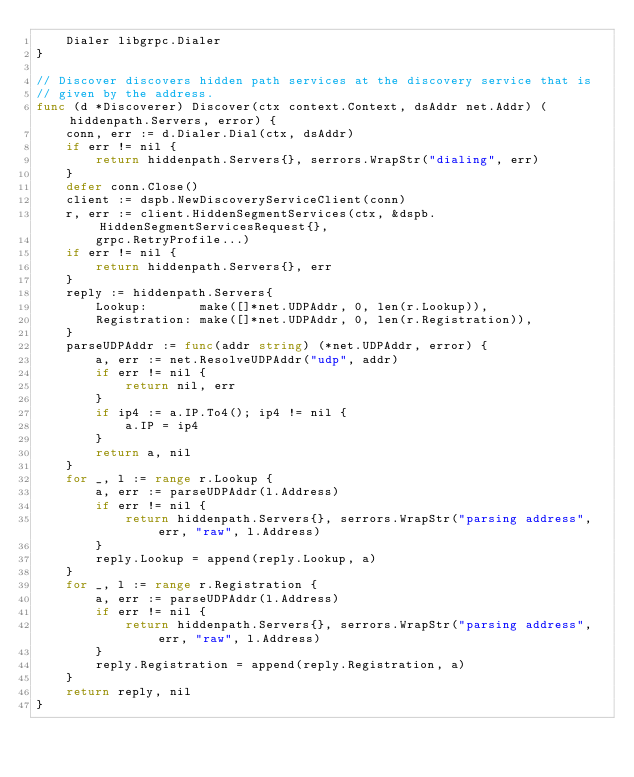Convert code to text. <code><loc_0><loc_0><loc_500><loc_500><_Go_>	Dialer libgrpc.Dialer
}

// Discover discovers hidden path services at the discovery service that is
// given by the address.
func (d *Discoverer) Discover(ctx context.Context, dsAddr net.Addr) (hiddenpath.Servers, error) {
	conn, err := d.Dialer.Dial(ctx, dsAddr)
	if err != nil {
		return hiddenpath.Servers{}, serrors.WrapStr("dialing", err)
	}
	defer conn.Close()
	client := dspb.NewDiscoveryServiceClient(conn)
	r, err := client.HiddenSegmentServices(ctx, &dspb.HiddenSegmentServicesRequest{},
		grpc.RetryProfile...)
	if err != nil {
		return hiddenpath.Servers{}, err
	}
	reply := hiddenpath.Servers{
		Lookup:       make([]*net.UDPAddr, 0, len(r.Lookup)),
		Registration: make([]*net.UDPAddr, 0, len(r.Registration)),
	}
	parseUDPAddr := func(addr string) (*net.UDPAddr, error) {
		a, err := net.ResolveUDPAddr("udp", addr)
		if err != nil {
			return nil, err
		}
		if ip4 := a.IP.To4(); ip4 != nil {
			a.IP = ip4
		}
		return a, nil
	}
	for _, l := range r.Lookup {
		a, err := parseUDPAddr(l.Address)
		if err != nil {
			return hiddenpath.Servers{}, serrors.WrapStr("parsing address", err, "raw", l.Address)
		}
		reply.Lookup = append(reply.Lookup, a)
	}
	for _, l := range r.Registration {
		a, err := parseUDPAddr(l.Address)
		if err != nil {
			return hiddenpath.Servers{}, serrors.WrapStr("parsing address", err, "raw", l.Address)
		}
		reply.Registration = append(reply.Registration, a)
	}
	return reply, nil
}
</code> 